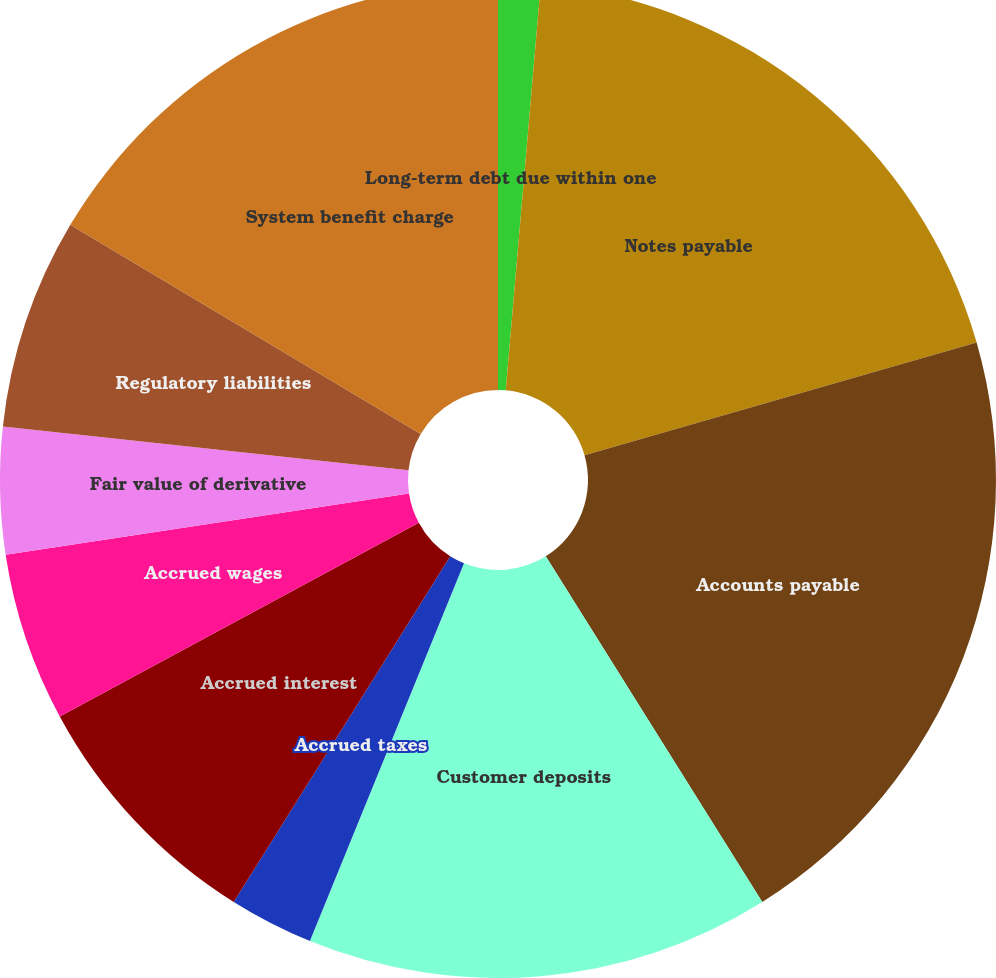Convert chart. <chart><loc_0><loc_0><loc_500><loc_500><pie_chart><fcel>Long-term debt due within one<fcel>Notes payable<fcel>Accounts payable<fcel>Customer deposits<fcel>Accrued taxes<fcel>Accrued interest<fcel>Accrued wages<fcel>Fair value of derivative<fcel>Regulatory liabilities<fcel>System benefit charge<nl><fcel>1.37%<fcel>19.18%<fcel>20.55%<fcel>15.07%<fcel>2.74%<fcel>8.22%<fcel>5.48%<fcel>4.11%<fcel>6.85%<fcel>16.44%<nl></chart> 